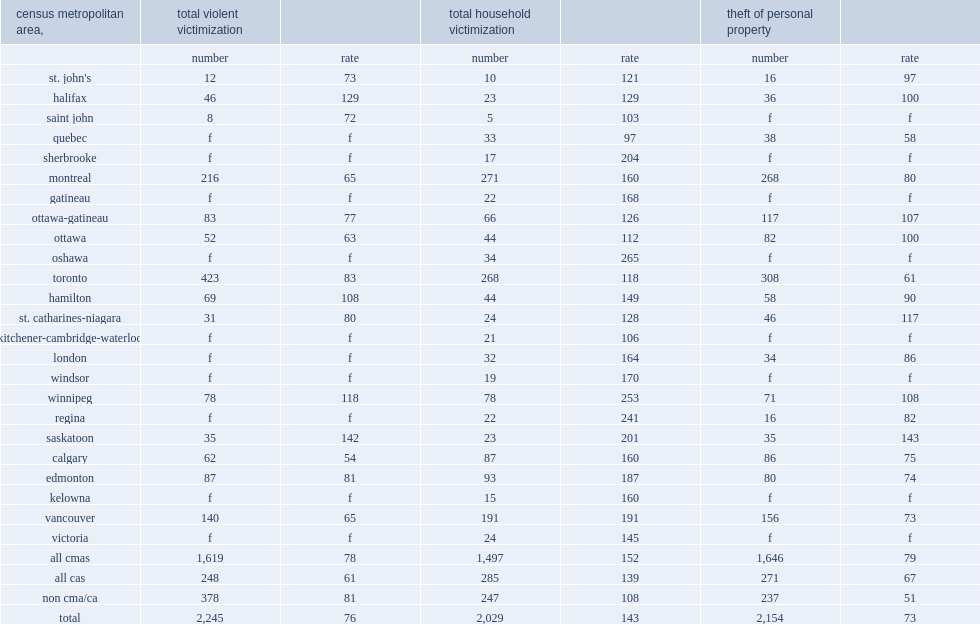In 2014, what the total violent victimization rates outside the cmas and cas compare to those of the cmas? 81.0. Among the cmas with a releasable violent victimization rate, which area recorded the highest rate? 129. Among the cmas with a releasable violent victimization rate, which area had the second highest rate? 118. What was the rate of household victimization in the cmas compare to that recorded in the cas? 152. 